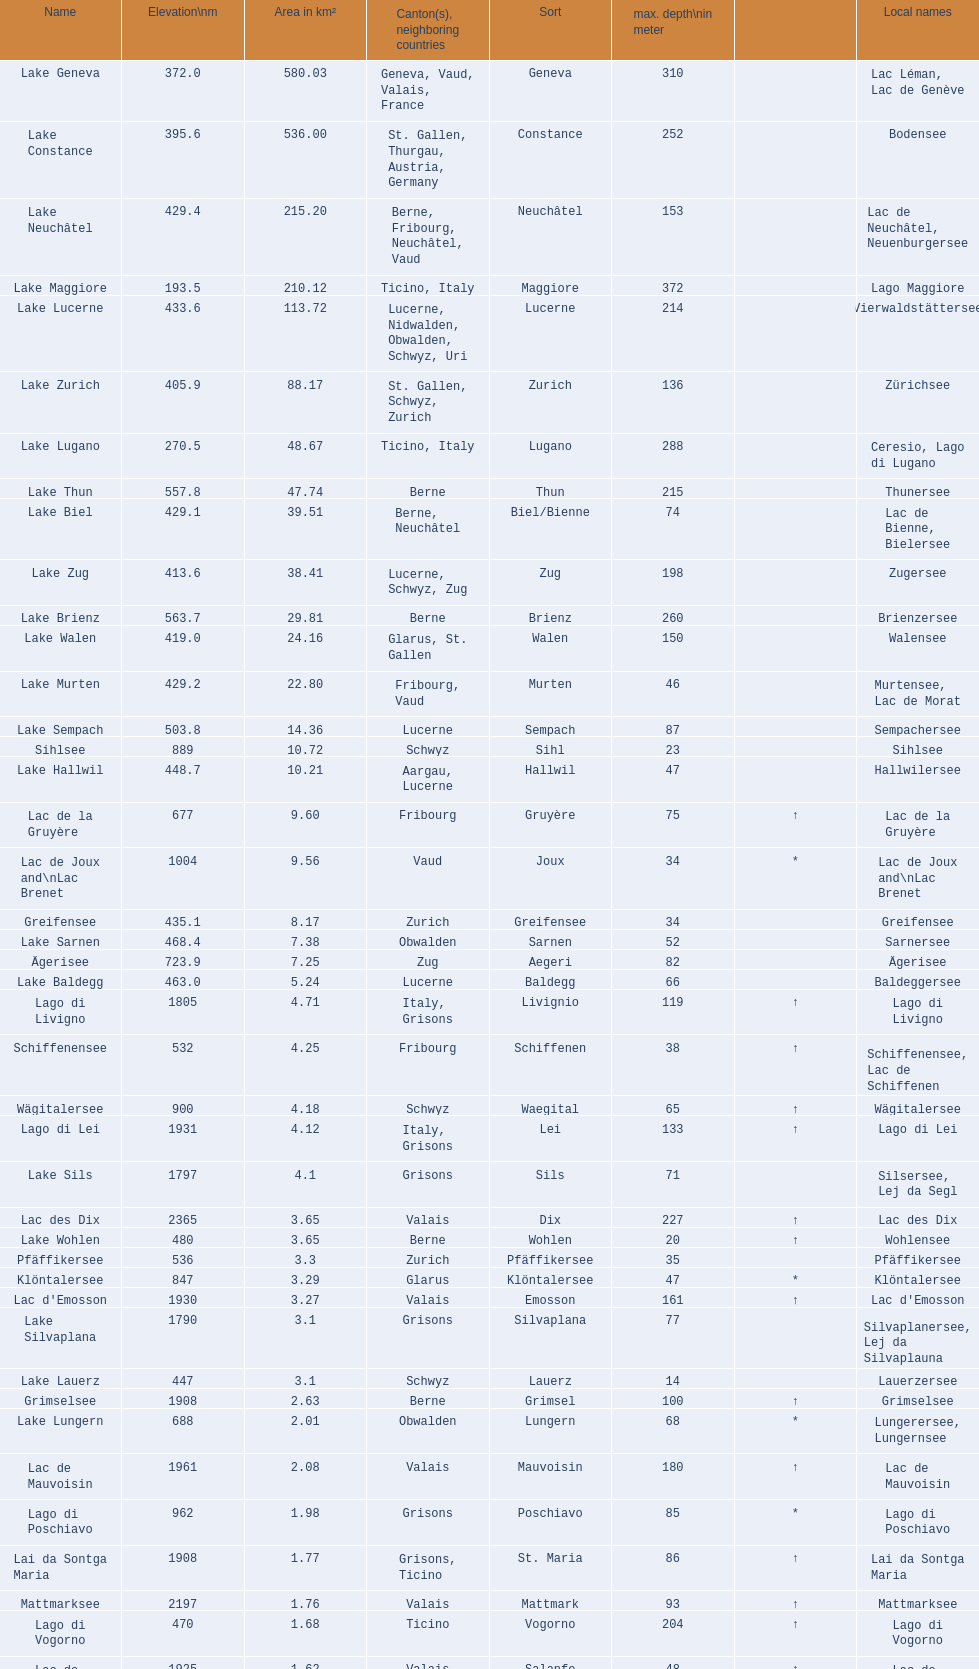Which lake has the greatest elevation? Lac des Dix. 